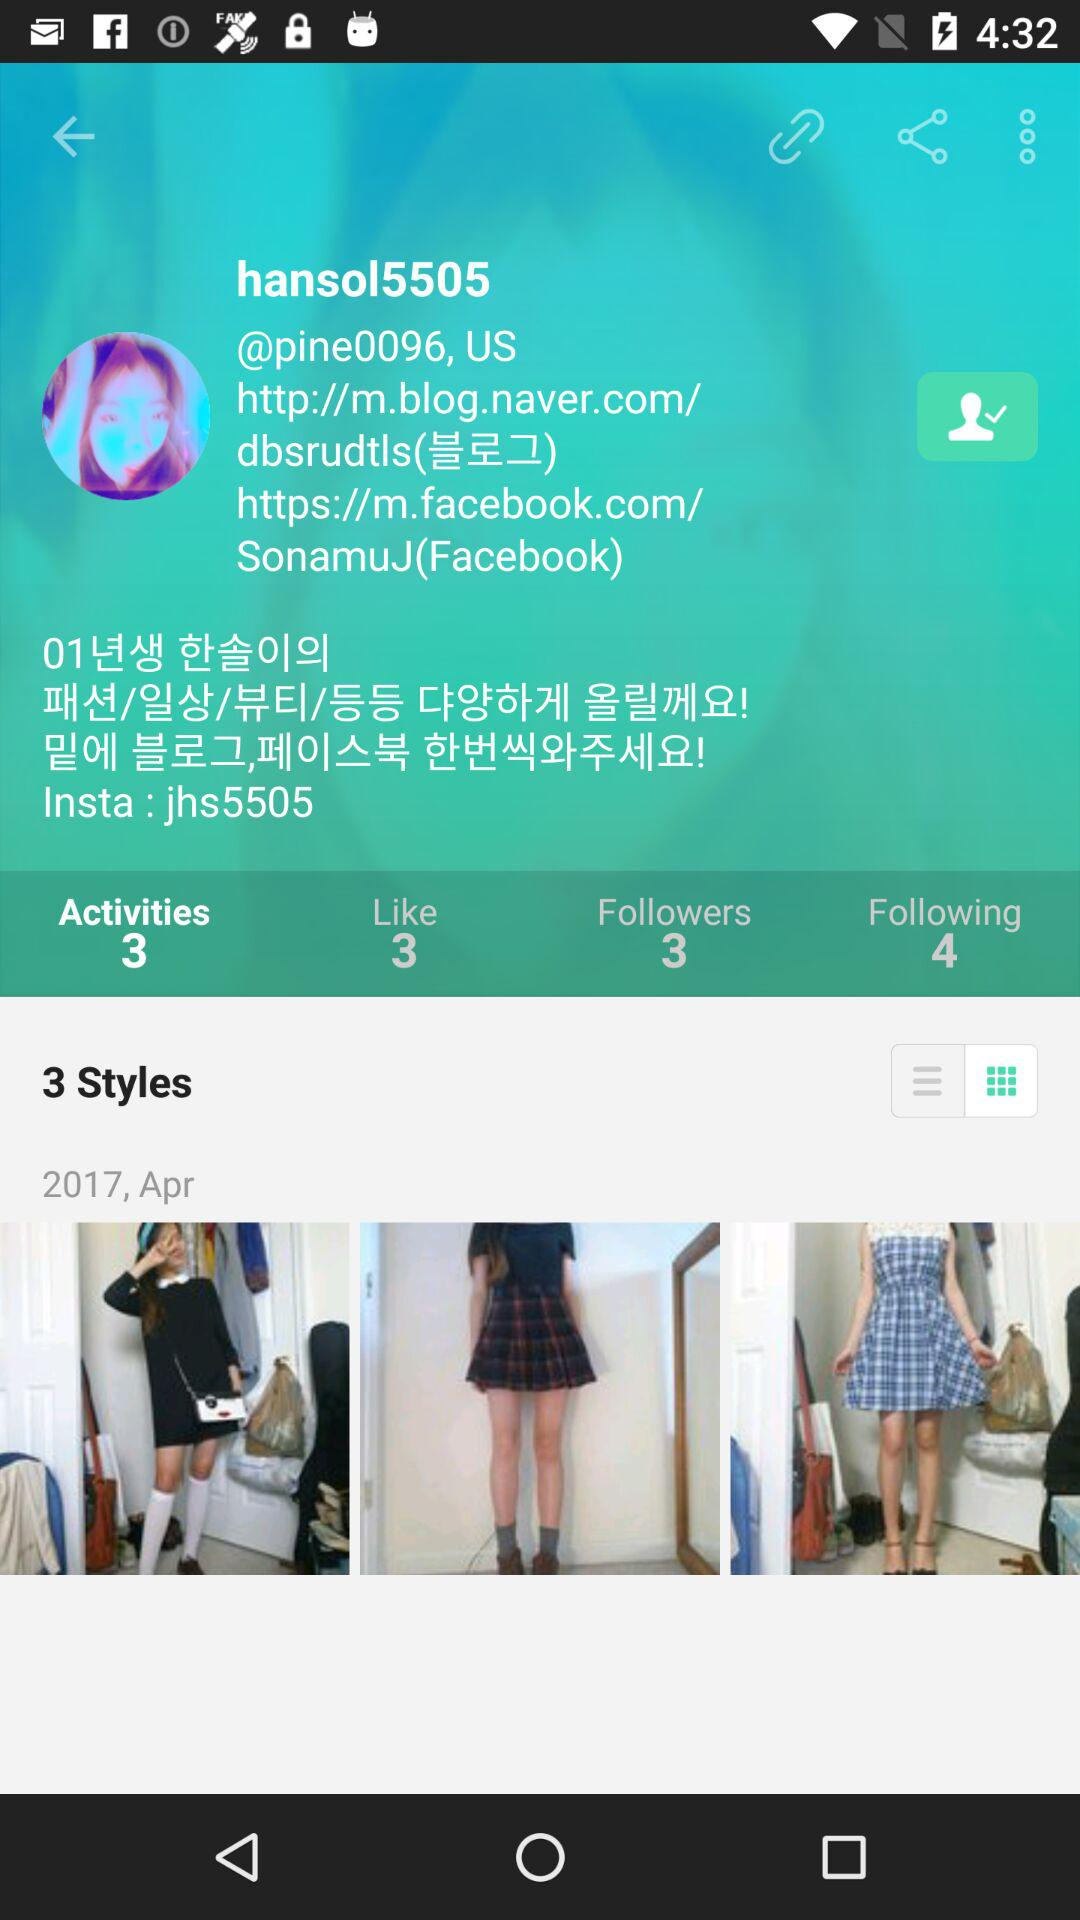What is the number of likes? The number of likes is 3. 